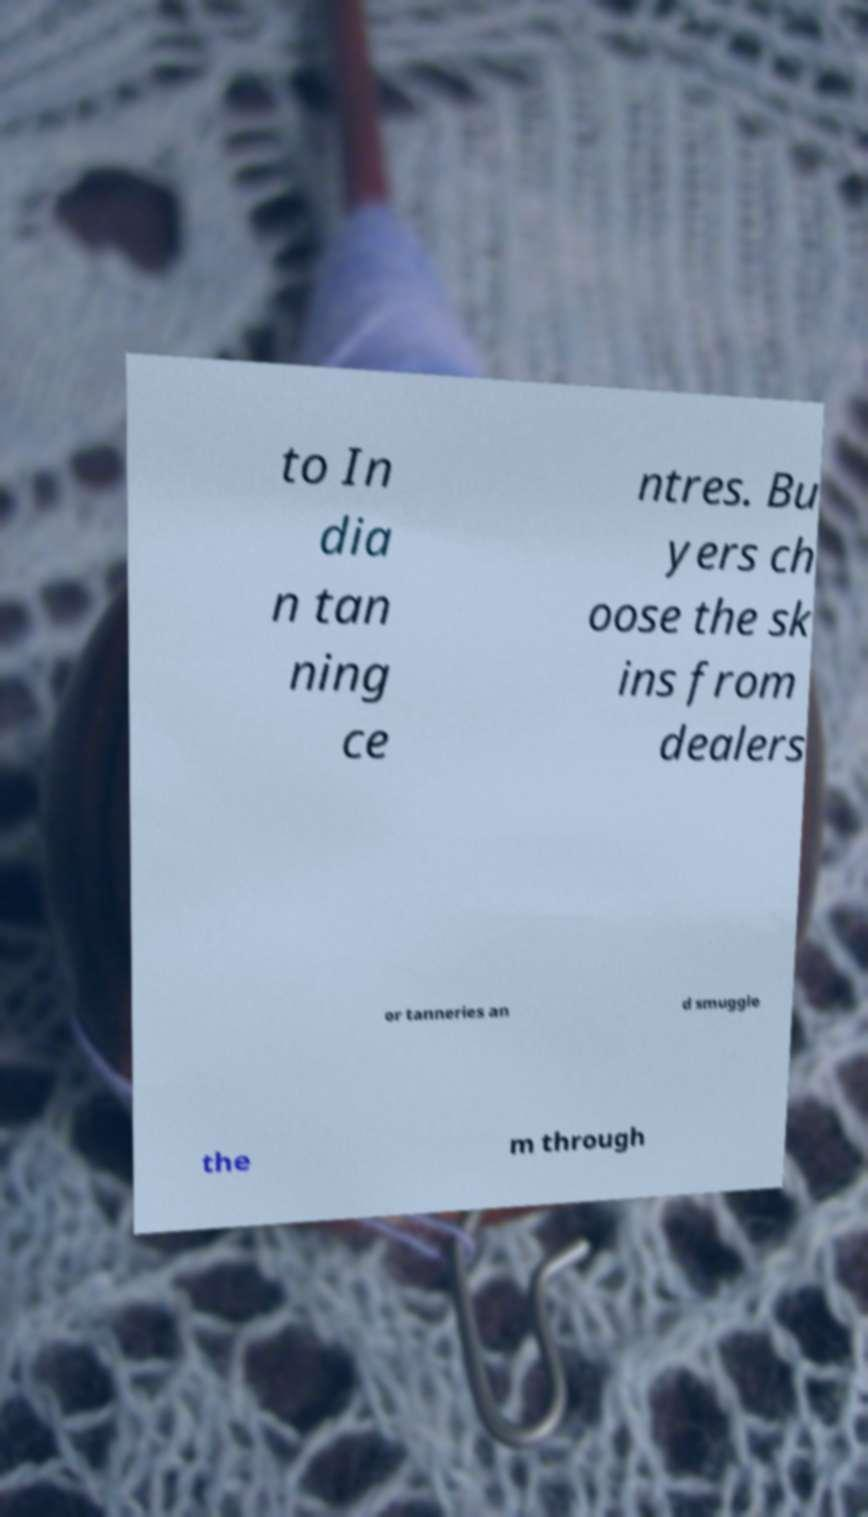There's text embedded in this image that I need extracted. Can you transcribe it verbatim? to In dia n tan ning ce ntres. Bu yers ch oose the sk ins from dealers or tanneries an d smuggle the m through 